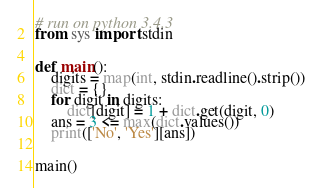Convert code to text. <code><loc_0><loc_0><loc_500><loc_500><_Python_># run on python 3.4.3
from sys import stdin


def main():
    digits = map(int, stdin.readline().strip())
    dict = {}
    for digit in digits:
        dict[digit] = 1 + dict.get(digit, 0)
    ans = 3 <= max(dict.values())
    print(['No', 'Yes'][ans])


main()
</code> 